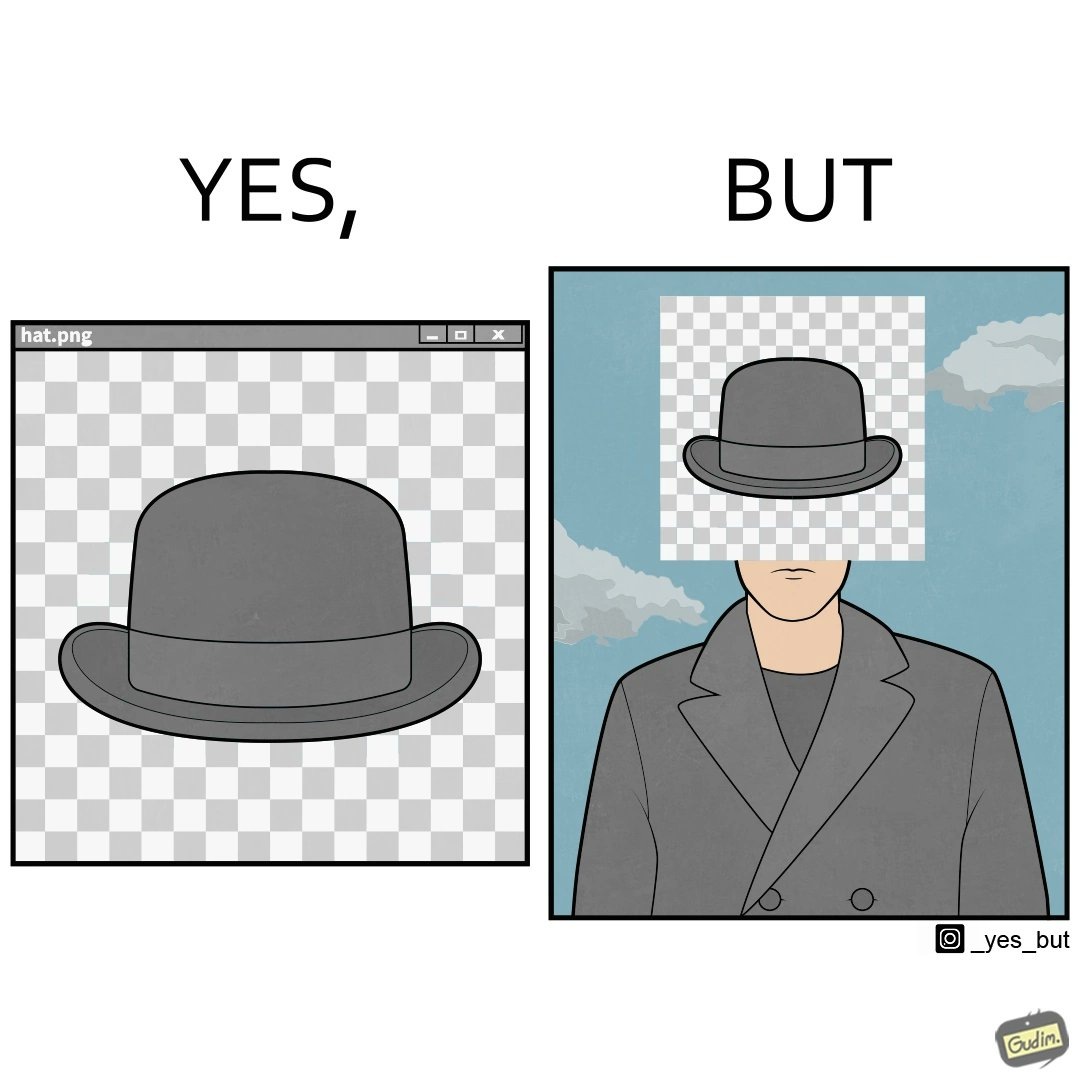Explain why this image is satirical. The images are funny since the .png image of the hat is supposed to have a transparent background but when the image is used for editing a mans picture it is seen that the background is not actually transparent and it ends up covering the face of the man in the other picture. 